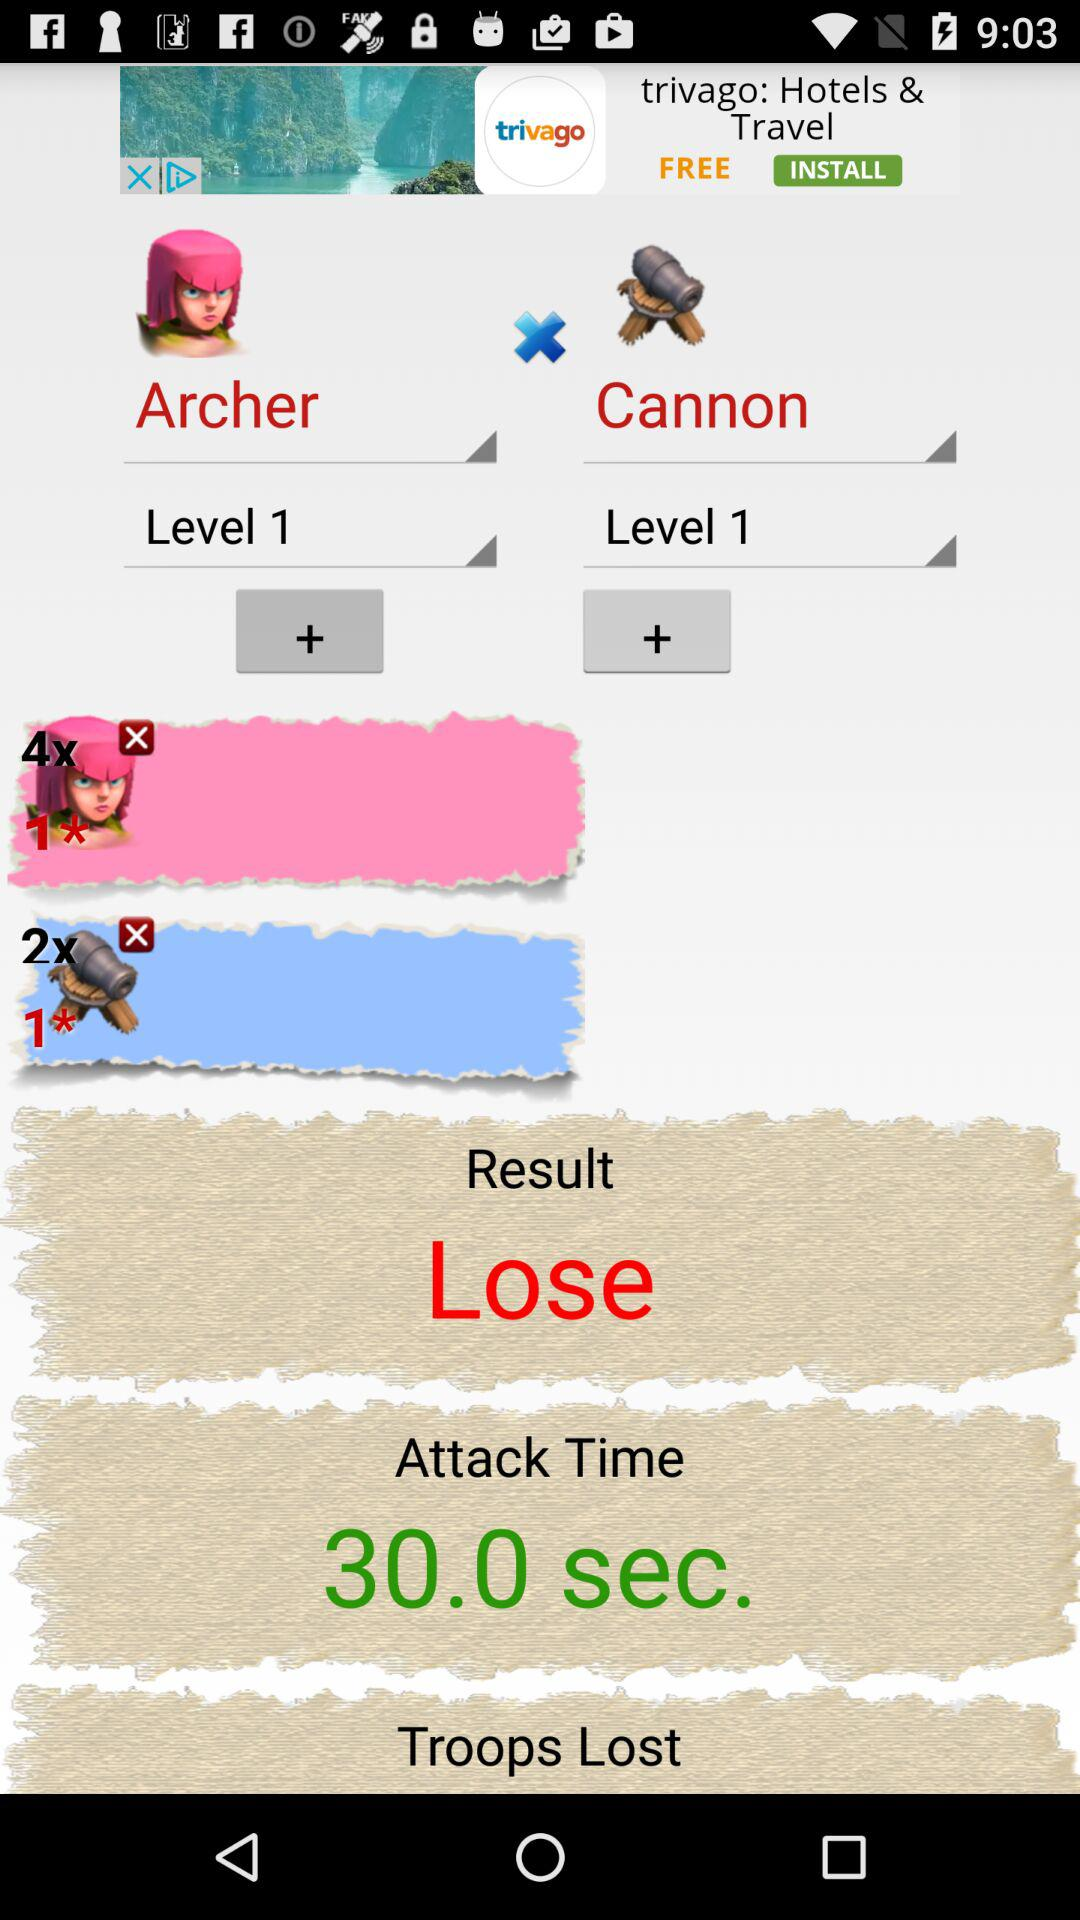What is the attack time? The attack time is 30 seconds. 